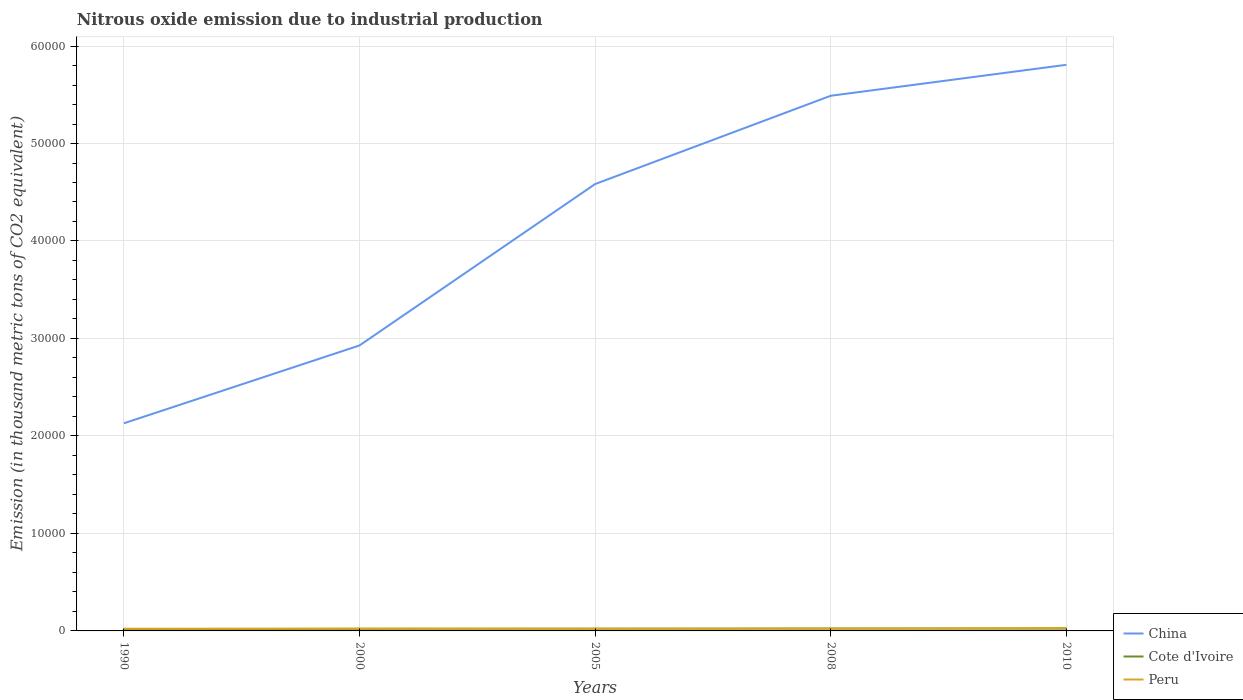How many different coloured lines are there?
Your response must be concise. 3. Does the line corresponding to Peru intersect with the line corresponding to China?
Ensure brevity in your answer.  No. Is the number of lines equal to the number of legend labels?
Your answer should be compact. Yes. Across all years, what is the maximum amount of nitrous oxide emitted in Cote d'Ivoire?
Provide a short and direct response. 171.6. In which year was the amount of nitrous oxide emitted in China maximum?
Ensure brevity in your answer.  1990. What is the total amount of nitrous oxide emitted in Peru in the graph?
Your answer should be very brief. -90.3. What is the difference between the highest and the second highest amount of nitrous oxide emitted in China?
Offer a very short reply. 3.68e+04. What is the difference between the highest and the lowest amount of nitrous oxide emitted in China?
Keep it short and to the point. 3. How many years are there in the graph?
Your answer should be compact. 5. What is the difference between two consecutive major ticks on the Y-axis?
Your answer should be compact. 10000. Are the values on the major ticks of Y-axis written in scientific E-notation?
Your response must be concise. No. Where does the legend appear in the graph?
Your response must be concise. Bottom right. What is the title of the graph?
Your response must be concise. Nitrous oxide emission due to industrial production. Does "Suriname" appear as one of the legend labels in the graph?
Your response must be concise. No. What is the label or title of the X-axis?
Your answer should be compact. Years. What is the label or title of the Y-axis?
Your response must be concise. Emission (in thousand metric tons of CO2 equivalent). What is the Emission (in thousand metric tons of CO2 equivalent) of China in 1990?
Your response must be concise. 2.13e+04. What is the Emission (in thousand metric tons of CO2 equivalent) of Cote d'Ivoire in 1990?
Ensure brevity in your answer.  171.6. What is the Emission (in thousand metric tons of CO2 equivalent) in Peru in 1990?
Give a very brief answer. 227.9. What is the Emission (in thousand metric tons of CO2 equivalent) in China in 2000?
Provide a short and direct response. 2.93e+04. What is the Emission (in thousand metric tons of CO2 equivalent) of Cote d'Ivoire in 2000?
Give a very brief answer. 214.7. What is the Emission (in thousand metric tons of CO2 equivalent) of Peru in 2000?
Provide a succinct answer. 235.2. What is the Emission (in thousand metric tons of CO2 equivalent) in China in 2005?
Keep it short and to the point. 4.58e+04. What is the Emission (in thousand metric tons of CO2 equivalent) of Cote d'Ivoire in 2005?
Give a very brief answer. 231.8. What is the Emission (in thousand metric tons of CO2 equivalent) in Peru in 2005?
Your answer should be compact. 217.8. What is the Emission (in thousand metric tons of CO2 equivalent) of China in 2008?
Give a very brief answer. 5.49e+04. What is the Emission (in thousand metric tons of CO2 equivalent) in Cote d'Ivoire in 2008?
Your answer should be very brief. 249.2. What is the Emission (in thousand metric tons of CO2 equivalent) of Peru in 2008?
Your answer should be very brief. 214.1. What is the Emission (in thousand metric tons of CO2 equivalent) of China in 2010?
Your answer should be very brief. 5.81e+04. What is the Emission (in thousand metric tons of CO2 equivalent) of Cote d'Ivoire in 2010?
Provide a succinct answer. 233.8. What is the Emission (in thousand metric tons of CO2 equivalent) in Peru in 2010?
Your answer should be compact. 304.4. Across all years, what is the maximum Emission (in thousand metric tons of CO2 equivalent) of China?
Your answer should be compact. 5.81e+04. Across all years, what is the maximum Emission (in thousand metric tons of CO2 equivalent) of Cote d'Ivoire?
Your answer should be compact. 249.2. Across all years, what is the maximum Emission (in thousand metric tons of CO2 equivalent) in Peru?
Ensure brevity in your answer.  304.4. Across all years, what is the minimum Emission (in thousand metric tons of CO2 equivalent) of China?
Ensure brevity in your answer.  2.13e+04. Across all years, what is the minimum Emission (in thousand metric tons of CO2 equivalent) of Cote d'Ivoire?
Offer a terse response. 171.6. Across all years, what is the minimum Emission (in thousand metric tons of CO2 equivalent) of Peru?
Offer a terse response. 214.1. What is the total Emission (in thousand metric tons of CO2 equivalent) in China in the graph?
Make the answer very short. 2.09e+05. What is the total Emission (in thousand metric tons of CO2 equivalent) in Cote d'Ivoire in the graph?
Give a very brief answer. 1101.1. What is the total Emission (in thousand metric tons of CO2 equivalent) in Peru in the graph?
Give a very brief answer. 1199.4. What is the difference between the Emission (in thousand metric tons of CO2 equivalent) of China in 1990 and that in 2000?
Offer a terse response. -7984.9. What is the difference between the Emission (in thousand metric tons of CO2 equivalent) of Cote d'Ivoire in 1990 and that in 2000?
Make the answer very short. -43.1. What is the difference between the Emission (in thousand metric tons of CO2 equivalent) of Peru in 1990 and that in 2000?
Provide a short and direct response. -7.3. What is the difference between the Emission (in thousand metric tons of CO2 equivalent) in China in 1990 and that in 2005?
Your answer should be compact. -2.45e+04. What is the difference between the Emission (in thousand metric tons of CO2 equivalent) in Cote d'Ivoire in 1990 and that in 2005?
Keep it short and to the point. -60.2. What is the difference between the Emission (in thousand metric tons of CO2 equivalent) of Peru in 1990 and that in 2005?
Give a very brief answer. 10.1. What is the difference between the Emission (in thousand metric tons of CO2 equivalent) in China in 1990 and that in 2008?
Ensure brevity in your answer.  -3.36e+04. What is the difference between the Emission (in thousand metric tons of CO2 equivalent) in Cote d'Ivoire in 1990 and that in 2008?
Offer a terse response. -77.6. What is the difference between the Emission (in thousand metric tons of CO2 equivalent) of Peru in 1990 and that in 2008?
Offer a very short reply. 13.8. What is the difference between the Emission (in thousand metric tons of CO2 equivalent) of China in 1990 and that in 2010?
Give a very brief answer. -3.68e+04. What is the difference between the Emission (in thousand metric tons of CO2 equivalent) in Cote d'Ivoire in 1990 and that in 2010?
Provide a short and direct response. -62.2. What is the difference between the Emission (in thousand metric tons of CO2 equivalent) of Peru in 1990 and that in 2010?
Offer a terse response. -76.5. What is the difference between the Emission (in thousand metric tons of CO2 equivalent) of China in 2000 and that in 2005?
Make the answer very short. -1.66e+04. What is the difference between the Emission (in thousand metric tons of CO2 equivalent) of Cote d'Ivoire in 2000 and that in 2005?
Provide a succinct answer. -17.1. What is the difference between the Emission (in thousand metric tons of CO2 equivalent) in Peru in 2000 and that in 2005?
Your answer should be very brief. 17.4. What is the difference between the Emission (in thousand metric tons of CO2 equivalent) in China in 2000 and that in 2008?
Give a very brief answer. -2.56e+04. What is the difference between the Emission (in thousand metric tons of CO2 equivalent) of Cote d'Ivoire in 2000 and that in 2008?
Make the answer very short. -34.5. What is the difference between the Emission (in thousand metric tons of CO2 equivalent) of Peru in 2000 and that in 2008?
Make the answer very short. 21.1. What is the difference between the Emission (in thousand metric tons of CO2 equivalent) in China in 2000 and that in 2010?
Your answer should be compact. -2.88e+04. What is the difference between the Emission (in thousand metric tons of CO2 equivalent) in Cote d'Ivoire in 2000 and that in 2010?
Your response must be concise. -19.1. What is the difference between the Emission (in thousand metric tons of CO2 equivalent) of Peru in 2000 and that in 2010?
Your response must be concise. -69.2. What is the difference between the Emission (in thousand metric tons of CO2 equivalent) of China in 2005 and that in 2008?
Give a very brief answer. -9056.8. What is the difference between the Emission (in thousand metric tons of CO2 equivalent) of Cote d'Ivoire in 2005 and that in 2008?
Offer a very short reply. -17.4. What is the difference between the Emission (in thousand metric tons of CO2 equivalent) of China in 2005 and that in 2010?
Ensure brevity in your answer.  -1.22e+04. What is the difference between the Emission (in thousand metric tons of CO2 equivalent) in Cote d'Ivoire in 2005 and that in 2010?
Offer a terse response. -2. What is the difference between the Emission (in thousand metric tons of CO2 equivalent) in Peru in 2005 and that in 2010?
Your answer should be very brief. -86.6. What is the difference between the Emission (in thousand metric tons of CO2 equivalent) of China in 2008 and that in 2010?
Your answer should be very brief. -3175.5. What is the difference between the Emission (in thousand metric tons of CO2 equivalent) of Peru in 2008 and that in 2010?
Offer a terse response. -90.3. What is the difference between the Emission (in thousand metric tons of CO2 equivalent) of China in 1990 and the Emission (in thousand metric tons of CO2 equivalent) of Cote d'Ivoire in 2000?
Your answer should be compact. 2.11e+04. What is the difference between the Emission (in thousand metric tons of CO2 equivalent) of China in 1990 and the Emission (in thousand metric tons of CO2 equivalent) of Peru in 2000?
Ensure brevity in your answer.  2.11e+04. What is the difference between the Emission (in thousand metric tons of CO2 equivalent) in Cote d'Ivoire in 1990 and the Emission (in thousand metric tons of CO2 equivalent) in Peru in 2000?
Your response must be concise. -63.6. What is the difference between the Emission (in thousand metric tons of CO2 equivalent) in China in 1990 and the Emission (in thousand metric tons of CO2 equivalent) in Cote d'Ivoire in 2005?
Ensure brevity in your answer.  2.11e+04. What is the difference between the Emission (in thousand metric tons of CO2 equivalent) of China in 1990 and the Emission (in thousand metric tons of CO2 equivalent) of Peru in 2005?
Make the answer very short. 2.11e+04. What is the difference between the Emission (in thousand metric tons of CO2 equivalent) of Cote d'Ivoire in 1990 and the Emission (in thousand metric tons of CO2 equivalent) of Peru in 2005?
Your answer should be compact. -46.2. What is the difference between the Emission (in thousand metric tons of CO2 equivalent) in China in 1990 and the Emission (in thousand metric tons of CO2 equivalent) in Cote d'Ivoire in 2008?
Give a very brief answer. 2.10e+04. What is the difference between the Emission (in thousand metric tons of CO2 equivalent) in China in 1990 and the Emission (in thousand metric tons of CO2 equivalent) in Peru in 2008?
Your answer should be compact. 2.11e+04. What is the difference between the Emission (in thousand metric tons of CO2 equivalent) of Cote d'Ivoire in 1990 and the Emission (in thousand metric tons of CO2 equivalent) of Peru in 2008?
Give a very brief answer. -42.5. What is the difference between the Emission (in thousand metric tons of CO2 equivalent) of China in 1990 and the Emission (in thousand metric tons of CO2 equivalent) of Cote d'Ivoire in 2010?
Offer a very short reply. 2.11e+04. What is the difference between the Emission (in thousand metric tons of CO2 equivalent) of China in 1990 and the Emission (in thousand metric tons of CO2 equivalent) of Peru in 2010?
Offer a terse response. 2.10e+04. What is the difference between the Emission (in thousand metric tons of CO2 equivalent) in Cote d'Ivoire in 1990 and the Emission (in thousand metric tons of CO2 equivalent) in Peru in 2010?
Give a very brief answer. -132.8. What is the difference between the Emission (in thousand metric tons of CO2 equivalent) of China in 2000 and the Emission (in thousand metric tons of CO2 equivalent) of Cote d'Ivoire in 2005?
Keep it short and to the point. 2.91e+04. What is the difference between the Emission (in thousand metric tons of CO2 equivalent) of China in 2000 and the Emission (in thousand metric tons of CO2 equivalent) of Peru in 2005?
Keep it short and to the point. 2.91e+04. What is the difference between the Emission (in thousand metric tons of CO2 equivalent) in Cote d'Ivoire in 2000 and the Emission (in thousand metric tons of CO2 equivalent) in Peru in 2005?
Your answer should be very brief. -3.1. What is the difference between the Emission (in thousand metric tons of CO2 equivalent) in China in 2000 and the Emission (in thousand metric tons of CO2 equivalent) in Cote d'Ivoire in 2008?
Give a very brief answer. 2.90e+04. What is the difference between the Emission (in thousand metric tons of CO2 equivalent) in China in 2000 and the Emission (in thousand metric tons of CO2 equivalent) in Peru in 2008?
Your response must be concise. 2.91e+04. What is the difference between the Emission (in thousand metric tons of CO2 equivalent) in Cote d'Ivoire in 2000 and the Emission (in thousand metric tons of CO2 equivalent) in Peru in 2008?
Your answer should be compact. 0.6. What is the difference between the Emission (in thousand metric tons of CO2 equivalent) in China in 2000 and the Emission (in thousand metric tons of CO2 equivalent) in Cote d'Ivoire in 2010?
Ensure brevity in your answer.  2.90e+04. What is the difference between the Emission (in thousand metric tons of CO2 equivalent) of China in 2000 and the Emission (in thousand metric tons of CO2 equivalent) of Peru in 2010?
Provide a short and direct response. 2.90e+04. What is the difference between the Emission (in thousand metric tons of CO2 equivalent) of Cote d'Ivoire in 2000 and the Emission (in thousand metric tons of CO2 equivalent) of Peru in 2010?
Your answer should be very brief. -89.7. What is the difference between the Emission (in thousand metric tons of CO2 equivalent) of China in 2005 and the Emission (in thousand metric tons of CO2 equivalent) of Cote d'Ivoire in 2008?
Make the answer very short. 4.56e+04. What is the difference between the Emission (in thousand metric tons of CO2 equivalent) in China in 2005 and the Emission (in thousand metric tons of CO2 equivalent) in Peru in 2008?
Give a very brief answer. 4.56e+04. What is the difference between the Emission (in thousand metric tons of CO2 equivalent) in China in 2005 and the Emission (in thousand metric tons of CO2 equivalent) in Cote d'Ivoire in 2010?
Your response must be concise. 4.56e+04. What is the difference between the Emission (in thousand metric tons of CO2 equivalent) in China in 2005 and the Emission (in thousand metric tons of CO2 equivalent) in Peru in 2010?
Keep it short and to the point. 4.55e+04. What is the difference between the Emission (in thousand metric tons of CO2 equivalent) of Cote d'Ivoire in 2005 and the Emission (in thousand metric tons of CO2 equivalent) of Peru in 2010?
Offer a very short reply. -72.6. What is the difference between the Emission (in thousand metric tons of CO2 equivalent) of China in 2008 and the Emission (in thousand metric tons of CO2 equivalent) of Cote d'Ivoire in 2010?
Give a very brief answer. 5.47e+04. What is the difference between the Emission (in thousand metric tons of CO2 equivalent) of China in 2008 and the Emission (in thousand metric tons of CO2 equivalent) of Peru in 2010?
Keep it short and to the point. 5.46e+04. What is the difference between the Emission (in thousand metric tons of CO2 equivalent) in Cote d'Ivoire in 2008 and the Emission (in thousand metric tons of CO2 equivalent) in Peru in 2010?
Your response must be concise. -55.2. What is the average Emission (in thousand metric tons of CO2 equivalent) of China per year?
Offer a terse response. 4.19e+04. What is the average Emission (in thousand metric tons of CO2 equivalent) of Cote d'Ivoire per year?
Offer a terse response. 220.22. What is the average Emission (in thousand metric tons of CO2 equivalent) of Peru per year?
Make the answer very short. 239.88. In the year 1990, what is the difference between the Emission (in thousand metric tons of CO2 equivalent) in China and Emission (in thousand metric tons of CO2 equivalent) in Cote d'Ivoire?
Make the answer very short. 2.11e+04. In the year 1990, what is the difference between the Emission (in thousand metric tons of CO2 equivalent) of China and Emission (in thousand metric tons of CO2 equivalent) of Peru?
Your answer should be compact. 2.11e+04. In the year 1990, what is the difference between the Emission (in thousand metric tons of CO2 equivalent) in Cote d'Ivoire and Emission (in thousand metric tons of CO2 equivalent) in Peru?
Keep it short and to the point. -56.3. In the year 2000, what is the difference between the Emission (in thousand metric tons of CO2 equivalent) in China and Emission (in thousand metric tons of CO2 equivalent) in Cote d'Ivoire?
Provide a short and direct response. 2.91e+04. In the year 2000, what is the difference between the Emission (in thousand metric tons of CO2 equivalent) of China and Emission (in thousand metric tons of CO2 equivalent) of Peru?
Your answer should be very brief. 2.90e+04. In the year 2000, what is the difference between the Emission (in thousand metric tons of CO2 equivalent) of Cote d'Ivoire and Emission (in thousand metric tons of CO2 equivalent) of Peru?
Offer a terse response. -20.5. In the year 2005, what is the difference between the Emission (in thousand metric tons of CO2 equivalent) in China and Emission (in thousand metric tons of CO2 equivalent) in Cote d'Ivoire?
Offer a very short reply. 4.56e+04. In the year 2005, what is the difference between the Emission (in thousand metric tons of CO2 equivalent) in China and Emission (in thousand metric tons of CO2 equivalent) in Peru?
Make the answer very short. 4.56e+04. In the year 2005, what is the difference between the Emission (in thousand metric tons of CO2 equivalent) of Cote d'Ivoire and Emission (in thousand metric tons of CO2 equivalent) of Peru?
Offer a very short reply. 14. In the year 2008, what is the difference between the Emission (in thousand metric tons of CO2 equivalent) of China and Emission (in thousand metric tons of CO2 equivalent) of Cote d'Ivoire?
Provide a short and direct response. 5.46e+04. In the year 2008, what is the difference between the Emission (in thousand metric tons of CO2 equivalent) in China and Emission (in thousand metric tons of CO2 equivalent) in Peru?
Your answer should be very brief. 5.47e+04. In the year 2008, what is the difference between the Emission (in thousand metric tons of CO2 equivalent) in Cote d'Ivoire and Emission (in thousand metric tons of CO2 equivalent) in Peru?
Ensure brevity in your answer.  35.1. In the year 2010, what is the difference between the Emission (in thousand metric tons of CO2 equivalent) in China and Emission (in thousand metric tons of CO2 equivalent) in Cote d'Ivoire?
Your answer should be compact. 5.78e+04. In the year 2010, what is the difference between the Emission (in thousand metric tons of CO2 equivalent) in China and Emission (in thousand metric tons of CO2 equivalent) in Peru?
Your answer should be very brief. 5.78e+04. In the year 2010, what is the difference between the Emission (in thousand metric tons of CO2 equivalent) of Cote d'Ivoire and Emission (in thousand metric tons of CO2 equivalent) of Peru?
Offer a very short reply. -70.6. What is the ratio of the Emission (in thousand metric tons of CO2 equivalent) in China in 1990 to that in 2000?
Make the answer very short. 0.73. What is the ratio of the Emission (in thousand metric tons of CO2 equivalent) in Cote d'Ivoire in 1990 to that in 2000?
Ensure brevity in your answer.  0.8. What is the ratio of the Emission (in thousand metric tons of CO2 equivalent) of Peru in 1990 to that in 2000?
Offer a very short reply. 0.97. What is the ratio of the Emission (in thousand metric tons of CO2 equivalent) of China in 1990 to that in 2005?
Your answer should be very brief. 0.46. What is the ratio of the Emission (in thousand metric tons of CO2 equivalent) in Cote d'Ivoire in 1990 to that in 2005?
Your answer should be compact. 0.74. What is the ratio of the Emission (in thousand metric tons of CO2 equivalent) of Peru in 1990 to that in 2005?
Your answer should be compact. 1.05. What is the ratio of the Emission (in thousand metric tons of CO2 equivalent) in China in 1990 to that in 2008?
Keep it short and to the point. 0.39. What is the ratio of the Emission (in thousand metric tons of CO2 equivalent) in Cote d'Ivoire in 1990 to that in 2008?
Offer a very short reply. 0.69. What is the ratio of the Emission (in thousand metric tons of CO2 equivalent) of Peru in 1990 to that in 2008?
Offer a terse response. 1.06. What is the ratio of the Emission (in thousand metric tons of CO2 equivalent) of China in 1990 to that in 2010?
Provide a succinct answer. 0.37. What is the ratio of the Emission (in thousand metric tons of CO2 equivalent) in Cote d'Ivoire in 1990 to that in 2010?
Provide a succinct answer. 0.73. What is the ratio of the Emission (in thousand metric tons of CO2 equivalent) of Peru in 1990 to that in 2010?
Give a very brief answer. 0.75. What is the ratio of the Emission (in thousand metric tons of CO2 equivalent) in China in 2000 to that in 2005?
Your response must be concise. 0.64. What is the ratio of the Emission (in thousand metric tons of CO2 equivalent) of Cote d'Ivoire in 2000 to that in 2005?
Your answer should be very brief. 0.93. What is the ratio of the Emission (in thousand metric tons of CO2 equivalent) in Peru in 2000 to that in 2005?
Make the answer very short. 1.08. What is the ratio of the Emission (in thousand metric tons of CO2 equivalent) of China in 2000 to that in 2008?
Give a very brief answer. 0.53. What is the ratio of the Emission (in thousand metric tons of CO2 equivalent) in Cote d'Ivoire in 2000 to that in 2008?
Offer a terse response. 0.86. What is the ratio of the Emission (in thousand metric tons of CO2 equivalent) in Peru in 2000 to that in 2008?
Make the answer very short. 1.1. What is the ratio of the Emission (in thousand metric tons of CO2 equivalent) of China in 2000 to that in 2010?
Your answer should be very brief. 0.5. What is the ratio of the Emission (in thousand metric tons of CO2 equivalent) of Cote d'Ivoire in 2000 to that in 2010?
Give a very brief answer. 0.92. What is the ratio of the Emission (in thousand metric tons of CO2 equivalent) of Peru in 2000 to that in 2010?
Your answer should be very brief. 0.77. What is the ratio of the Emission (in thousand metric tons of CO2 equivalent) in China in 2005 to that in 2008?
Ensure brevity in your answer.  0.83. What is the ratio of the Emission (in thousand metric tons of CO2 equivalent) in Cote d'Ivoire in 2005 to that in 2008?
Give a very brief answer. 0.93. What is the ratio of the Emission (in thousand metric tons of CO2 equivalent) of Peru in 2005 to that in 2008?
Your answer should be very brief. 1.02. What is the ratio of the Emission (in thousand metric tons of CO2 equivalent) in China in 2005 to that in 2010?
Offer a very short reply. 0.79. What is the ratio of the Emission (in thousand metric tons of CO2 equivalent) in Cote d'Ivoire in 2005 to that in 2010?
Keep it short and to the point. 0.99. What is the ratio of the Emission (in thousand metric tons of CO2 equivalent) in Peru in 2005 to that in 2010?
Ensure brevity in your answer.  0.72. What is the ratio of the Emission (in thousand metric tons of CO2 equivalent) in China in 2008 to that in 2010?
Provide a succinct answer. 0.95. What is the ratio of the Emission (in thousand metric tons of CO2 equivalent) in Cote d'Ivoire in 2008 to that in 2010?
Ensure brevity in your answer.  1.07. What is the ratio of the Emission (in thousand metric tons of CO2 equivalent) in Peru in 2008 to that in 2010?
Give a very brief answer. 0.7. What is the difference between the highest and the second highest Emission (in thousand metric tons of CO2 equivalent) of China?
Offer a terse response. 3175.5. What is the difference between the highest and the second highest Emission (in thousand metric tons of CO2 equivalent) of Cote d'Ivoire?
Provide a succinct answer. 15.4. What is the difference between the highest and the second highest Emission (in thousand metric tons of CO2 equivalent) in Peru?
Ensure brevity in your answer.  69.2. What is the difference between the highest and the lowest Emission (in thousand metric tons of CO2 equivalent) of China?
Make the answer very short. 3.68e+04. What is the difference between the highest and the lowest Emission (in thousand metric tons of CO2 equivalent) of Cote d'Ivoire?
Offer a very short reply. 77.6. What is the difference between the highest and the lowest Emission (in thousand metric tons of CO2 equivalent) of Peru?
Make the answer very short. 90.3. 